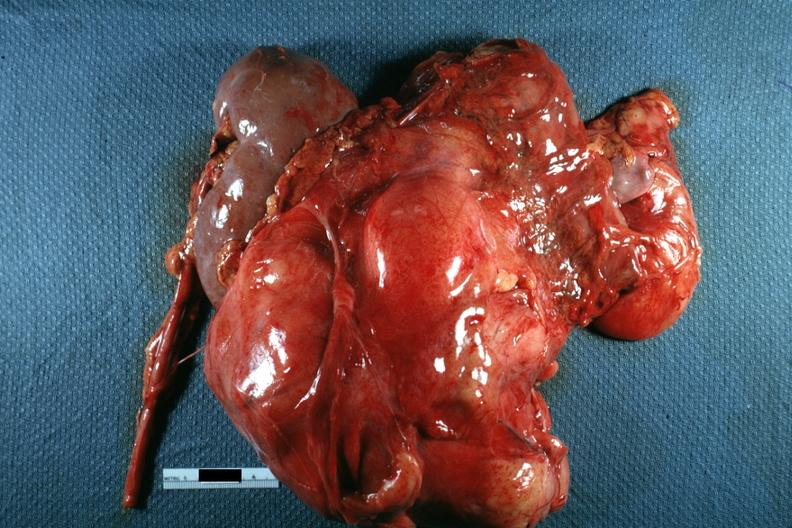s peritoneum present?
Answer the question using a single word or phrase. Yes 